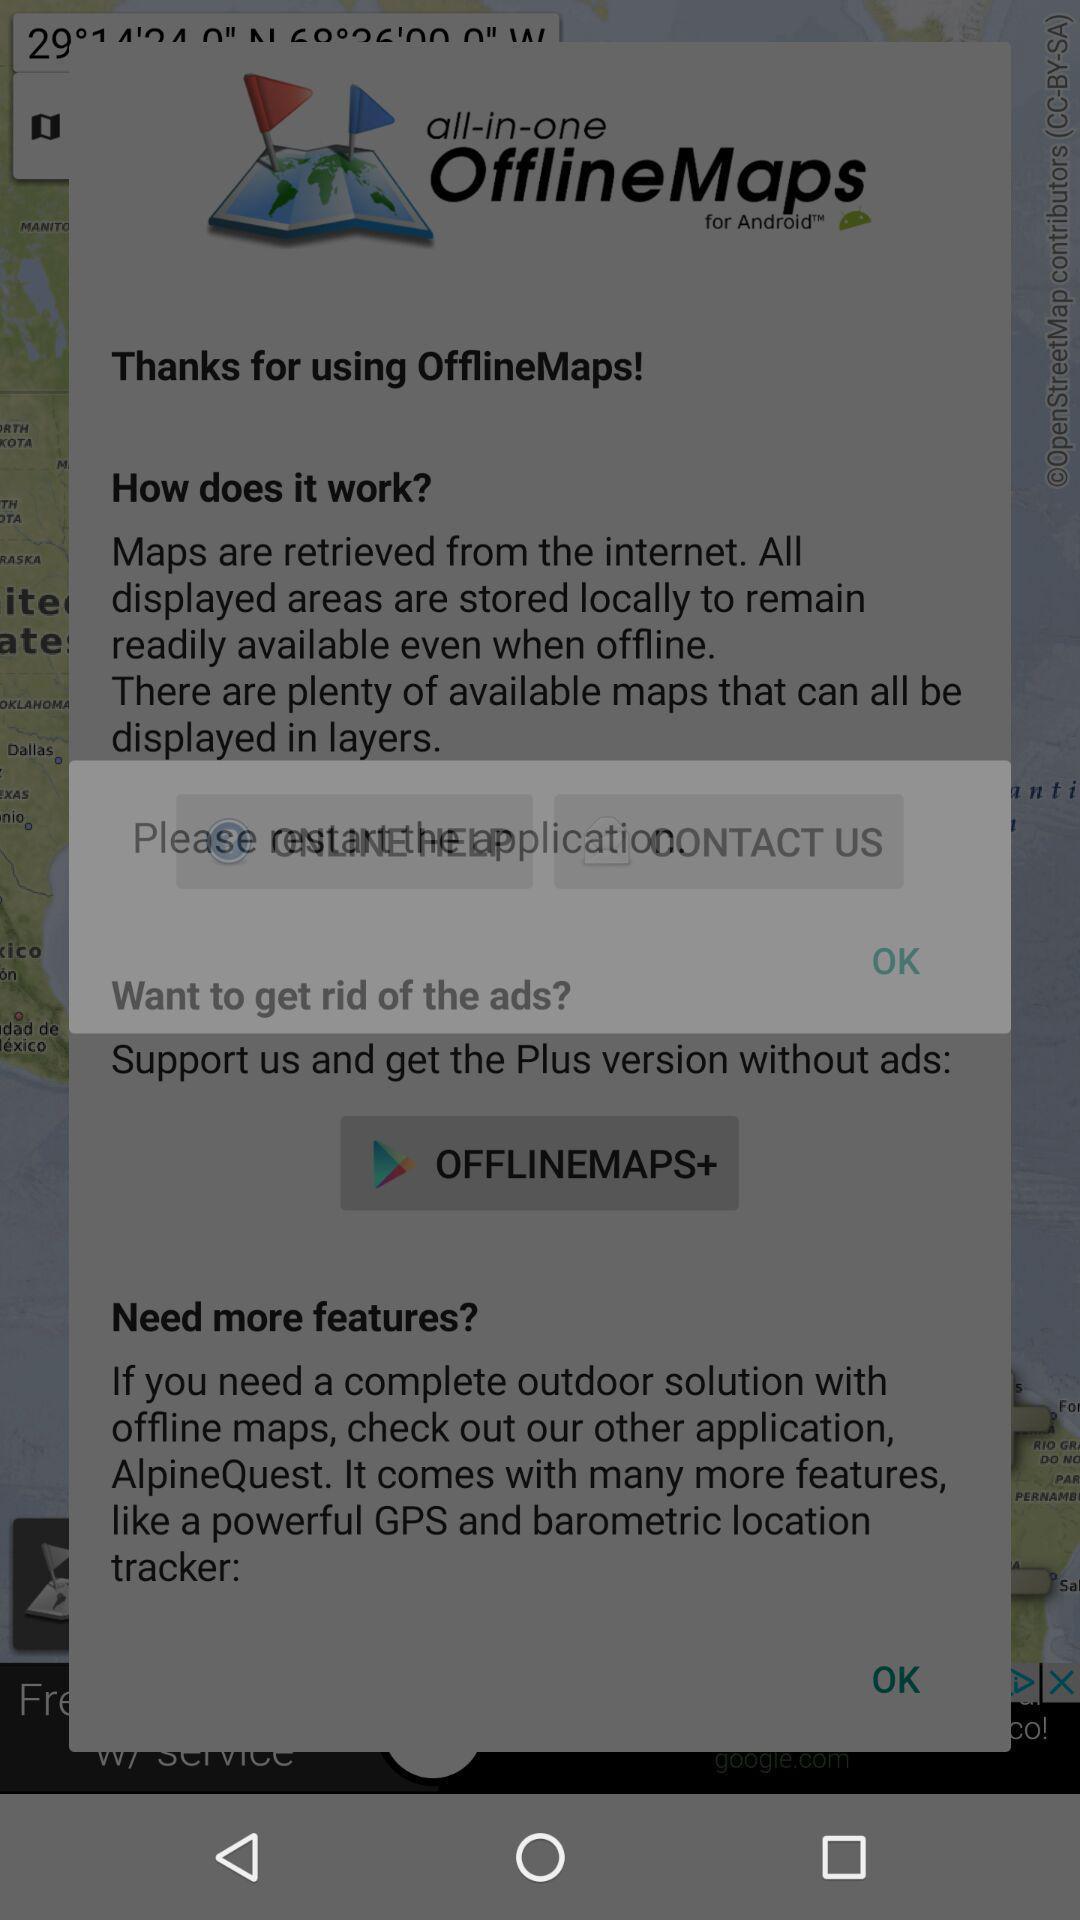Tell me what you see in this picture. Screen showing about page. 